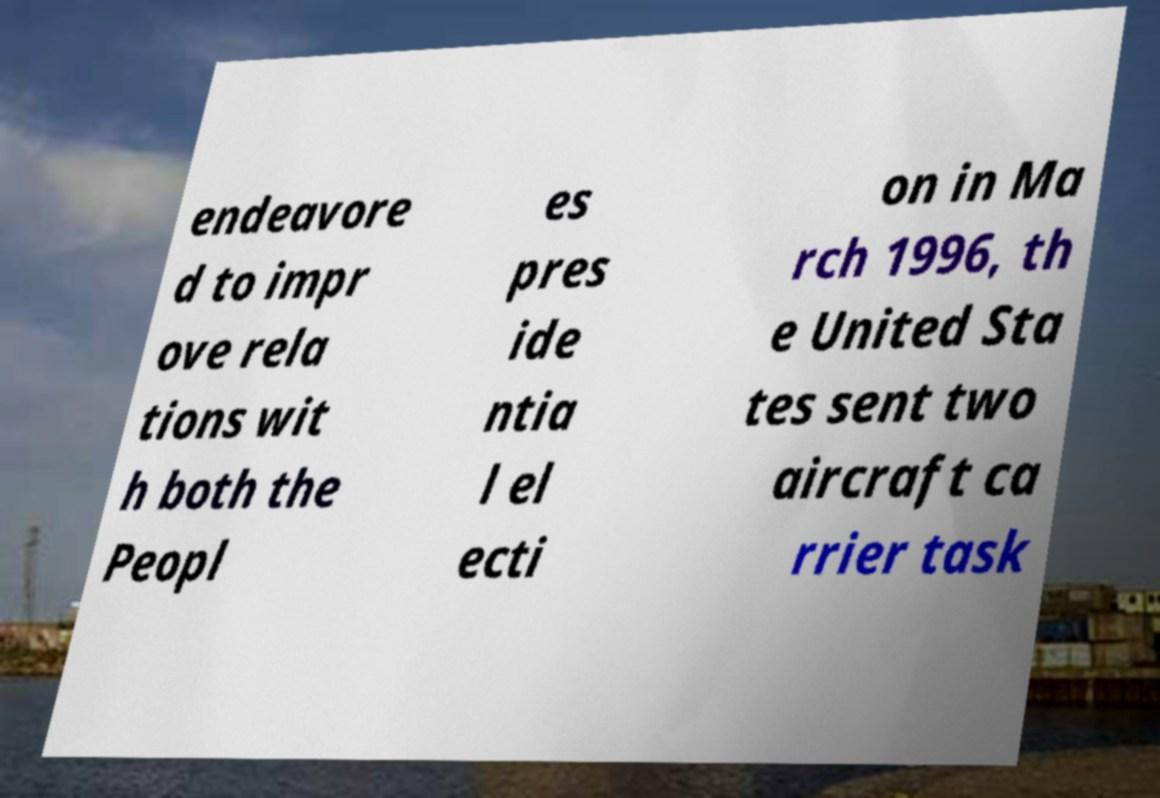Could you extract and type out the text from this image? endeavore d to impr ove rela tions wit h both the Peopl es pres ide ntia l el ecti on in Ma rch 1996, th e United Sta tes sent two aircraft ca rrier task 